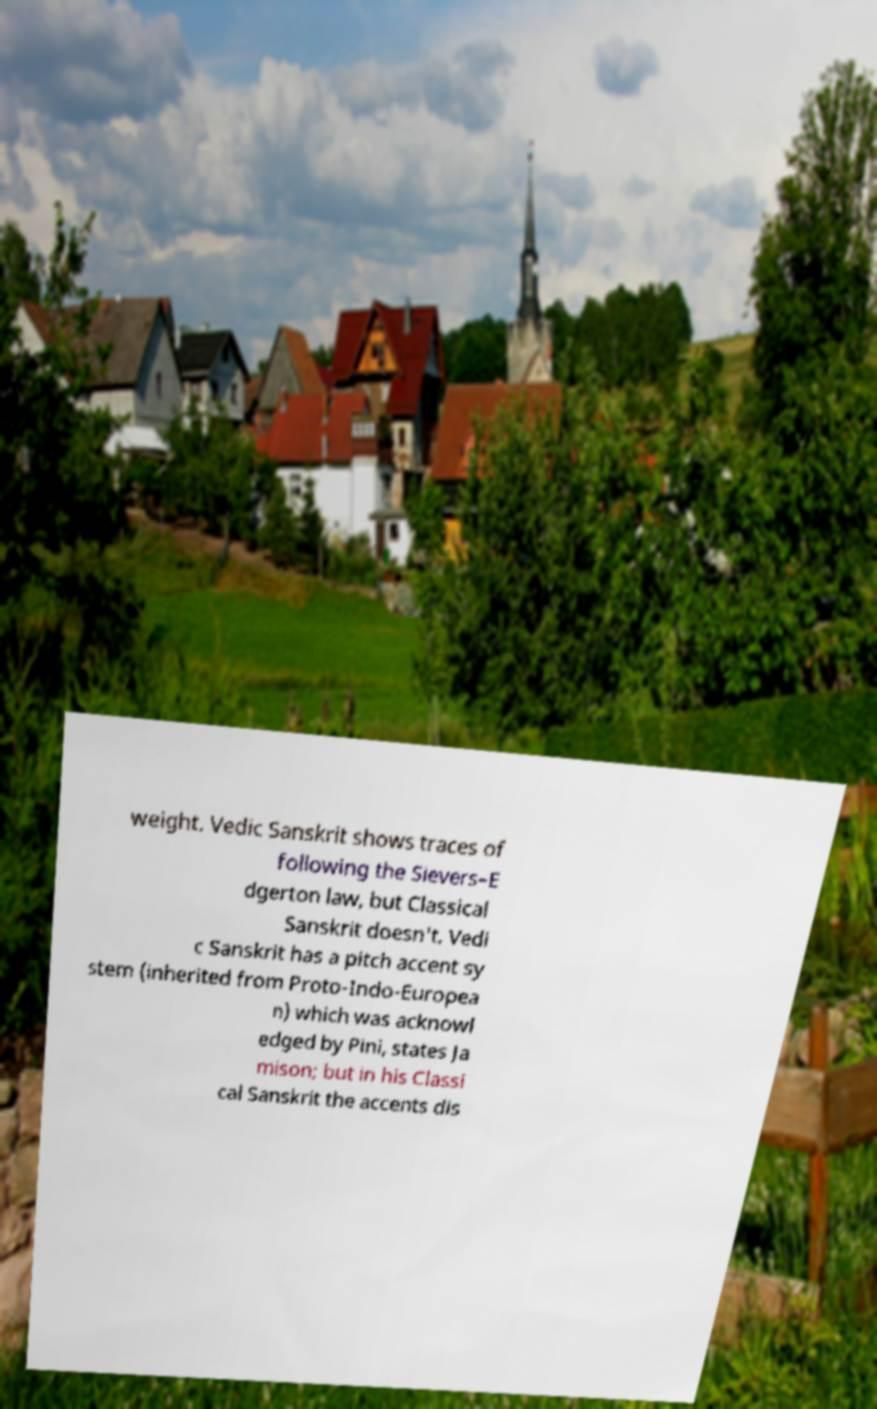I need the written content from this picture converted into text. Can you do that? weight. Vedic Sanskrit shows traces of following the Sievers–E dgerton law, but Classical Sanskrit doesn't. Vedi c Sanskrit has a pitch accent sy stem (inherited from Proto-Indo-Europea n) which was acknowl edged by Pini, states Ja mison; but in his Classi cal Sanskrit the accents dis 